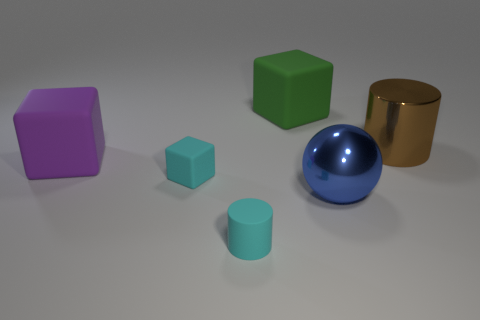Add 1 purple objects. How many objects exist? 7 Subtract all cylinders. How many objects are left? 4 Subtract all cyan matte objects. Subtract all red objects. How many objects are left? 4 Add 6 big brown metallic cylinders. How many big brown metallic cylinders are left? 7 Add 6 small brown cylinders. How many small brown cylinders exist? 6 Subtract 0 red cubes. How many objects are left? 6 